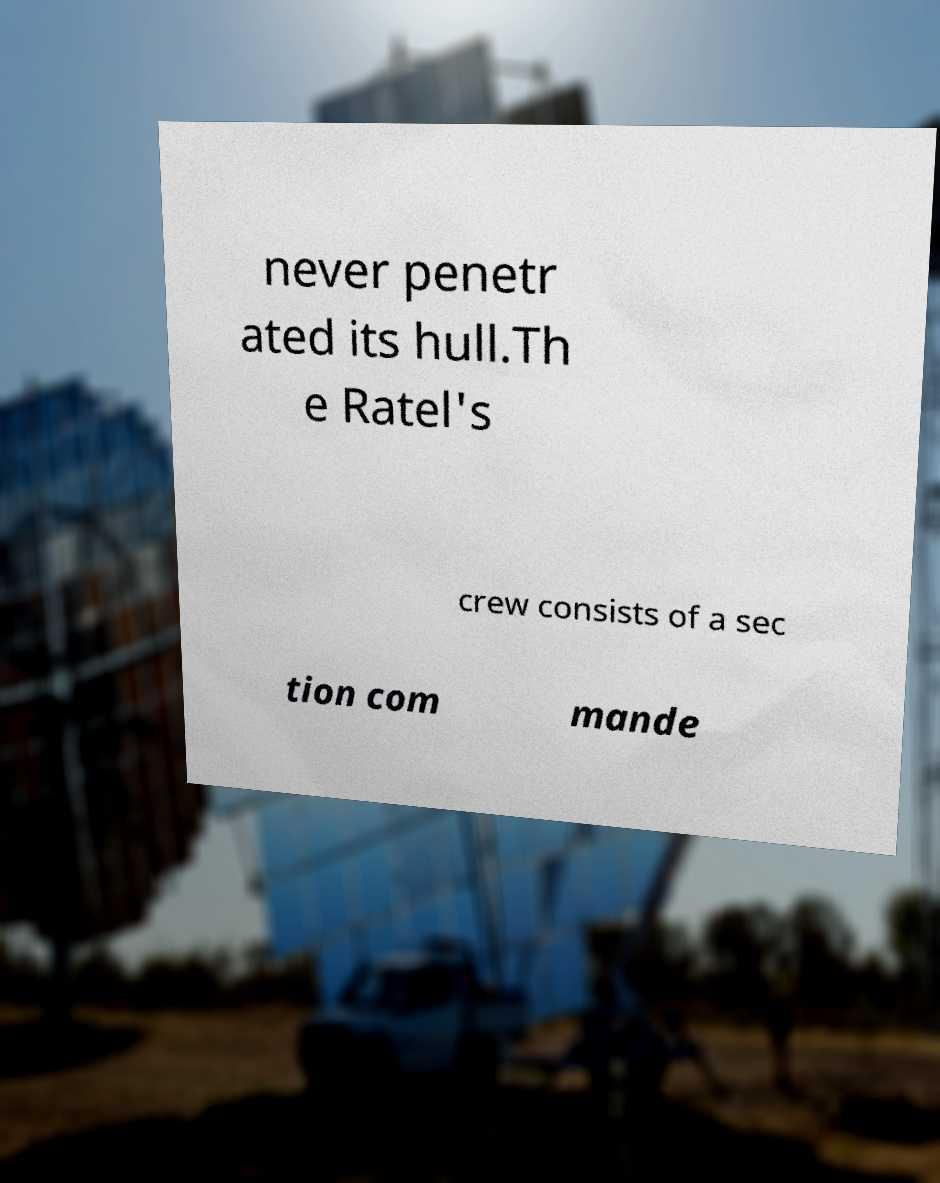Please identify and transcribe the text found in this image. never penetr ated its hull.Th e Ratel's crew consists of a sec tion com mande 